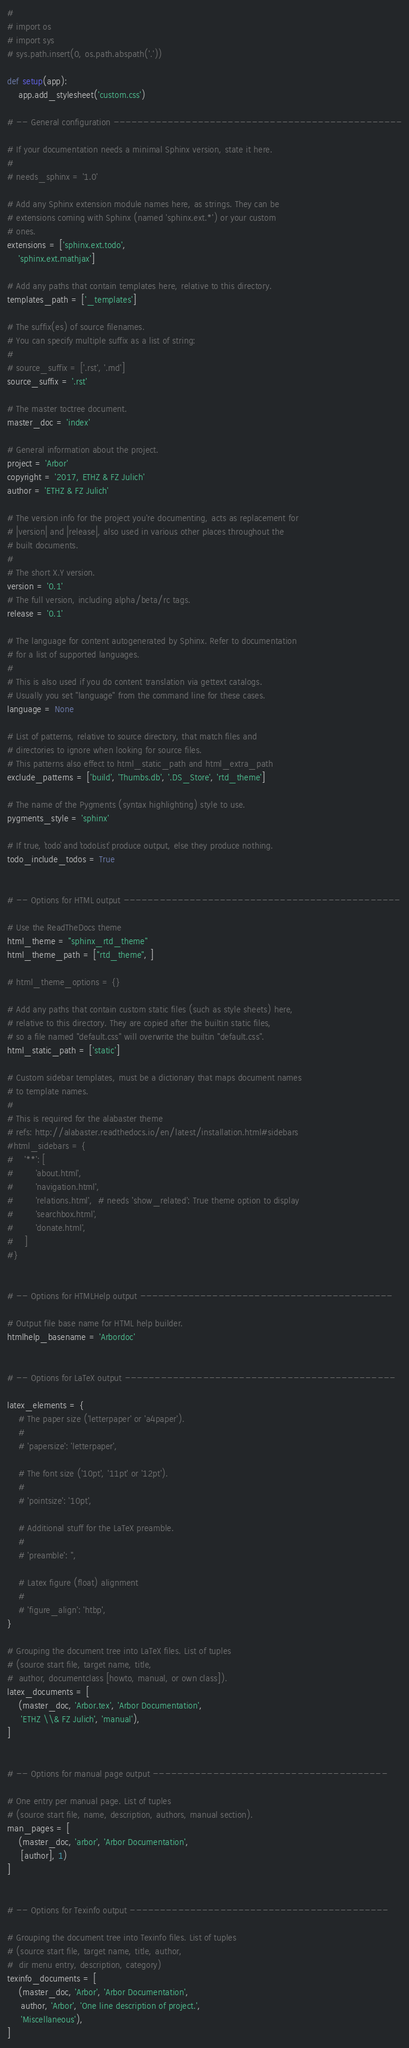Convert code to text. <code><loc_0><loc_0><loc_500><loc_500><_Python_>#
# import os
# import sys
# sys.path.insert(0, os.path.abspath('.'))

def setup(app):
    app.add_stylesheet('custom.css')

# -- General configuration ------------------------------------------------

# If your documentation needs a minimal Sphinx version, state it here.
#
# needs_sphinx = '1.0'

# Add any Sphinx extension module names here, as strings. They can be
# extensions coming with Sphinx (named 'sphinx.ext.*') or your custom
# ones.
extensions = ['sphinx.ext.todo',
    'sphinx.ext.mathjax']

# Add any paths that contain templates here, relative to this directory.
templates_path = ['_templates']

# The suffix(es) of source filenames.
# You can specify multiple suffix as a list of string:
#
# source_suffix = ['.rst', '.md']
source_suffix = '.rst'

# The master toctree document.
master_doc = 'index'

# General information about the project.
project = 'Arbor'
copyright = '2017, ETHZ & FZ Julich'
author = 'ETHZ & FZ Julich'

# The version info for the project you're documenting, acts as replacement for
# |version| and |release|, also used in various other places throughout the
# built documents.
#
# The short X.Y version.
version = '0.1'
# The full version, including alpha/beta/rc tags.
release = '0.1'

# The language for content autogenerated by Sphinx. Refer to documentation
# for a list of supported languages.
#
# This is also used if you do content translation via gettext catalogs.
# Usually you set "language" from the command line for these cases.
language = None

# List of patterns, relative to source directory, that match files and
# directories to ignore when looking for source files.
# This patterns also effect to html_static_path and html_extra_path
exclude_patterns = ['build', 'Thumbs.db', '.DS_Store', 'rtd_theme']

# The name of the Pygments (syntax highlighting) style to use.
pygments_style = 'sphinx'

# If true, `todo` and `todoList` produce output, else they produce nothing.
todo_include_todos = True


# -- Options for HTML output ----------------------------------------------

# Use the ReadTheDocs theme
html_theme = "sphinx_rtd_theme"
html_theme_path = ["rtd_theme", ]

# html_theme_options = {}

# Add any paths that contain custom static files (such as style sheets) here,
# relative to this directory. They are copied after the builtin static files,
# so a file named "default.css" will overwrite the builtin "default.css".
html_static_path = ['static']

# Custom sidebar templates, must be a dictionary that maps document names
# to template names.
#
# This is required for the alabaster theme
# refs: http://alabaster.readthedocs.io/en/latest/installation.html#sidebars
#html_sidebars = {
#    '**': [
#        'about.html',
#        'navigation.html',
#        'relations.html',  # needs 'show_related': True theme option to display
#        'searchbox.html',
#        'donate.html',
#    ]
#}


# -- Options for HTMLHelp output ------------------------------------------

# Output file base name for HTML help builder.
htmlhelp_basename = 'Arbordoc'


# -- Options for LaTeX output ---------------------------------------------

latex_elements = {
    # The paper size ('letterpaper' or 'a4paper').
    #
    # 'papersize': 'letterpaper',

    # The font size ('10pt', '11pt' or '12pt').
    #
    # 'pointsize': '10pt',

    # Additional stuff for the LaTeX preamble.
    #
    # 'preamble': '',

    # Latex figure (float) alignment
    #
    # 'figure_align': 'htbp',
}

# Grouping the document tree into LaTeX files. List of tuples
# (source start file, target name, title,
#  author, documentclass [howto, manual, or own class]).
latex_documents = [
    (master_doc, 'Arbor.tex', 'Arbor Documentation',
     'ETHZ \\& FZ Julich', 'manual'),
]


# -- Options for manual page output ---------------------------------------

# One entry per manual page. List of tuples
# (source start file, name, description, authors, manual section).
man_pages = [
    (master_doc, 'arbor', 'Arbor Documentation',
     [author], 1)
]


# -- Options for Texinfo output -------------------------------------------

# Grouping the document tree into Texinfo files. List of tuples
# (source start file, target name, title, author,
#  dir menu entry, description, category)
texinfo_documents = [
    (master_doc, 'Arbor', 'Arbor Documentation',
     author, 'Arbor', 'One line description of project.',
     'Miscellaneous'),
]
</code> 